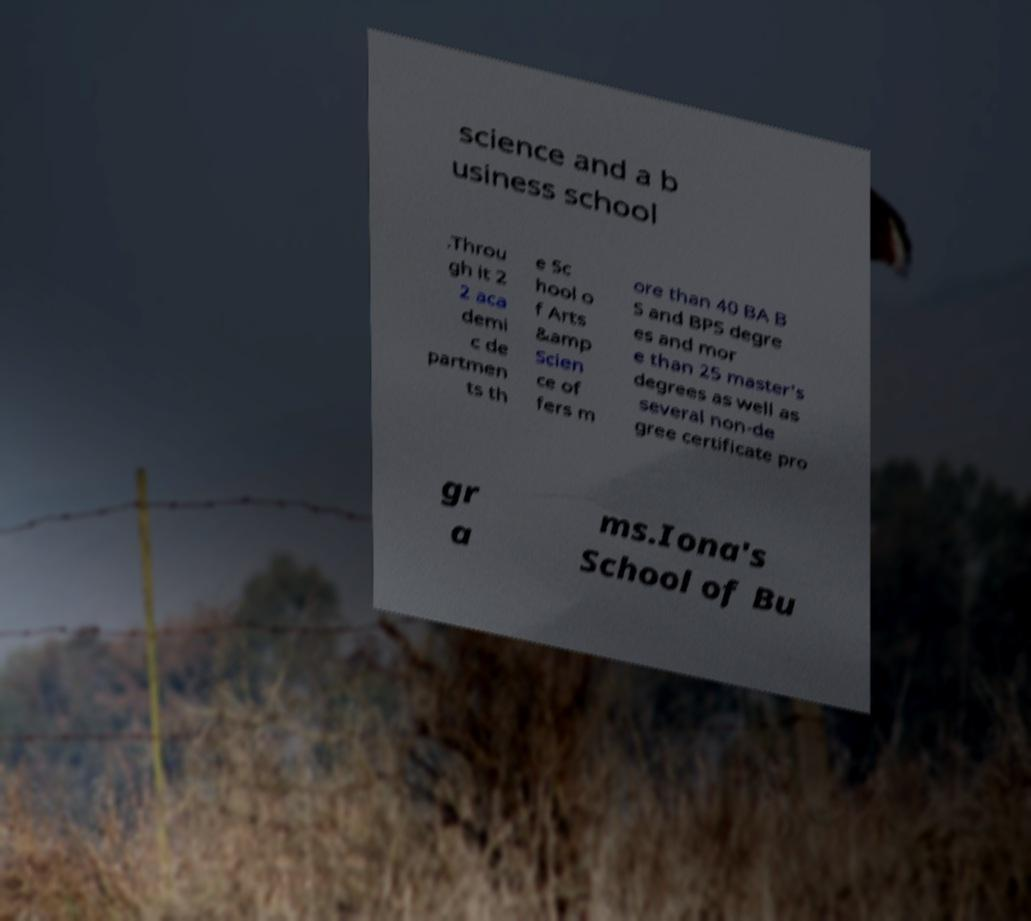Could you extract and type out the text from this image? science and a b usiness school .Throu gh it 2 2 aca demi c de partmen ts th e Sc hool o f Arts &amp Scien ce of fers m ore than 40 BA B S and BPS degre es and mor e than 25 master's degrees as well as several non-de gree certificate pro gr a ms.Iona's School of Bu 